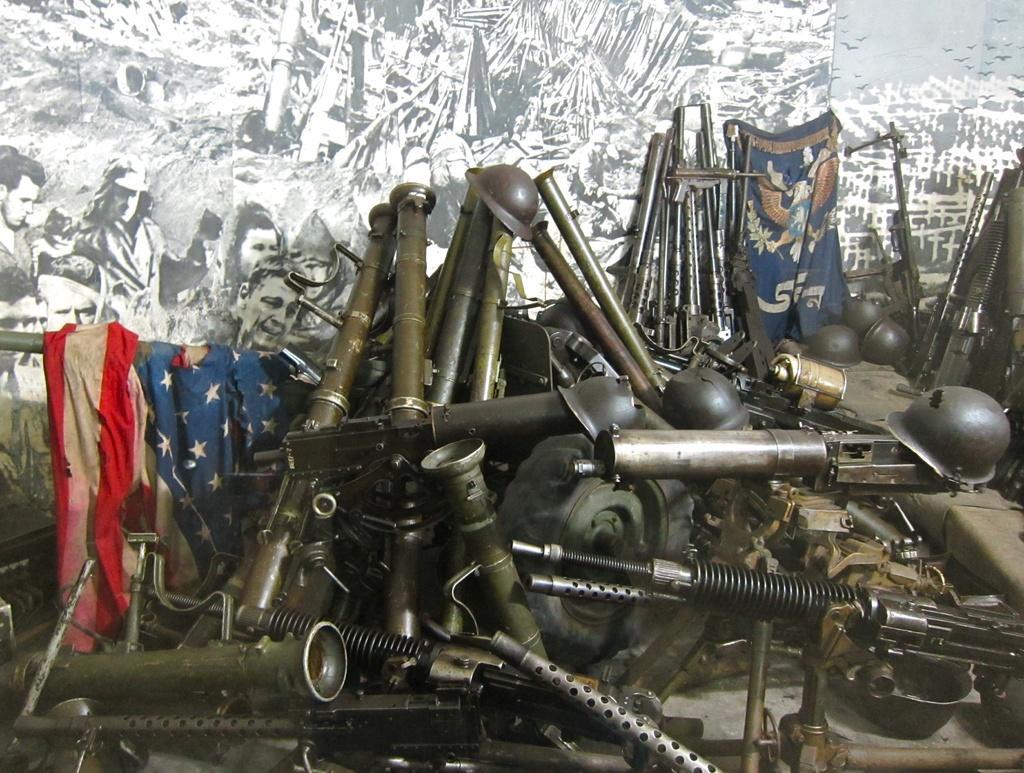Describe this image in one or two sentences. There are different types of weapons and helmets made up of metal are kept in front of a wall and on the wall there are different types of paintings are done. 